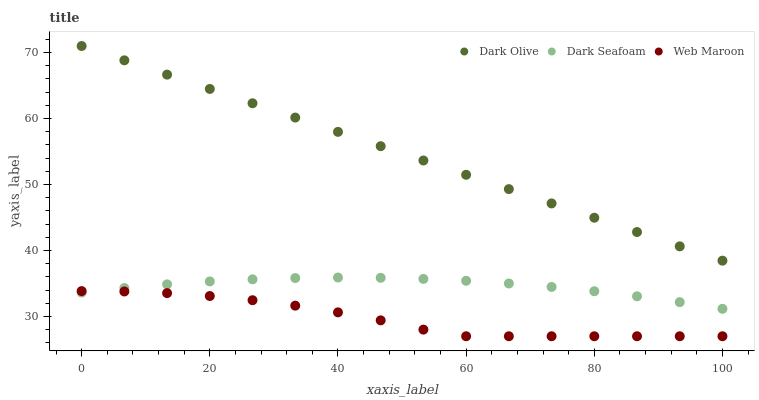Does Web Maroon have the minimum area under the curve?
Answer yes or no. Yes. Does Dark Olive have the maximum area under the curve?
Answer yes or no. Yes. Does Dark Olive have the minimum area under the curve?
Answer yes or no. No. Does Web Maroon have the maximum area under the curve?
Answer yes or no. No. Is Dark Olive the smoothest?
Answer yes or no. Yes. Is Web Maroon the roughest?
Answer yes or no. Yes. Is Web Maroon the smoothest?
Answer yes or no. No. Is Dark Olive the roughest?
Answer yes or no. No. Does Web Maroon have the lowest value?
Answer yes or no. Yes. Does Dark Olive have the lowest value?
Answer yes or no. No. Does Dark Olive have the highest value?
Answer yes or no. Yes. Does Web Maroon have the highest value?
Answer yes or no. No. Is Dark Seafoam less than Dark Olive?
Answer yes or no. Yes. Is Dark Olive greater than Dark Seafoam?
Answer yes or no. Yes. Does Dark Seafoam intersect Web Maroon?
Answer yes or no. Yes. Is Dark Seafoam less than Web Maroon?
Answer yes or no. No. Is Dark Seafoam greater than Web Maroon?
Answer yes or no. No. Does Dark Seafoam intersect Dark Olive?
Answer yes or no. No. 